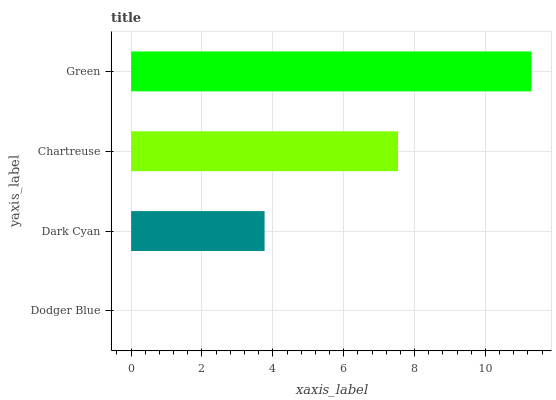Is Dodger Blue the minimum?
Answer yes or no. Yes. Is Green the maximum?
Answer yes or no. Yes. Is Dark Cyan the minimum?
Answer yes or no. No. Is Dark Cyan the maximum?
Answer yes or no. No. Is Dark Cyan greater than Dodger Blue?
Answer yes or no. Yes. Is Dodger Blue less than Dark Cyan?
Answer yes or no. Yes. Is Dodger Blue greater than Dark Cyan?
Answer yes or no. No. Is Dark Cyan less than Dodger Blue?
Answer yes or no. No. Is Chartreuse the high median?
Answer yes or no. Yes. Is Dark Cyan the low median?
Answer yes or no. Yes. Is Dark Cyan the high median?
Answer yes or no. No. Is Dodger Blue the low median?
Answer yes or no. No. 